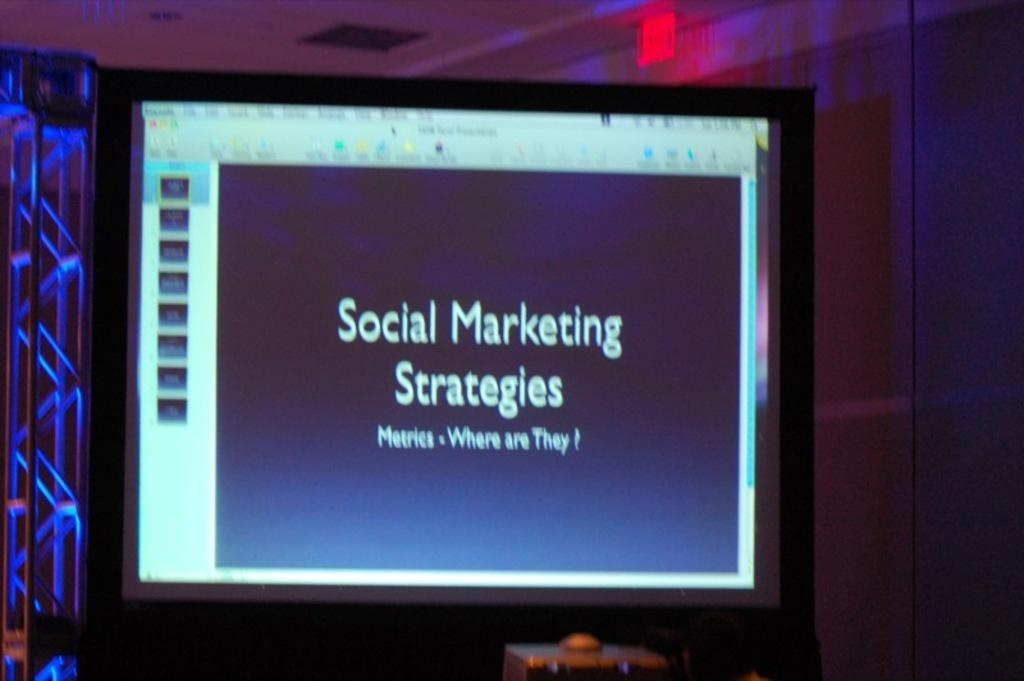<image>
Provide a brief description of the given image. Computer screen that says "Social Marketing Strategies" on it. 